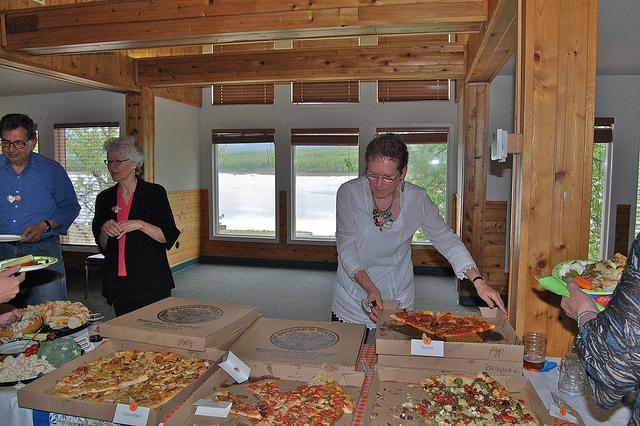Is this a store?
Write a very short answer. No. Are they having a party?
Give a very brief answer. Yes. What is the lady pulling?
Concise answer only. Pizza box. Is it daytime outside?
Short answer required. Yes. How many people are wearing eyeglasses at the table?
Short answer required. 3. What food are they serving?
Give a very brief answer. Pizza. 